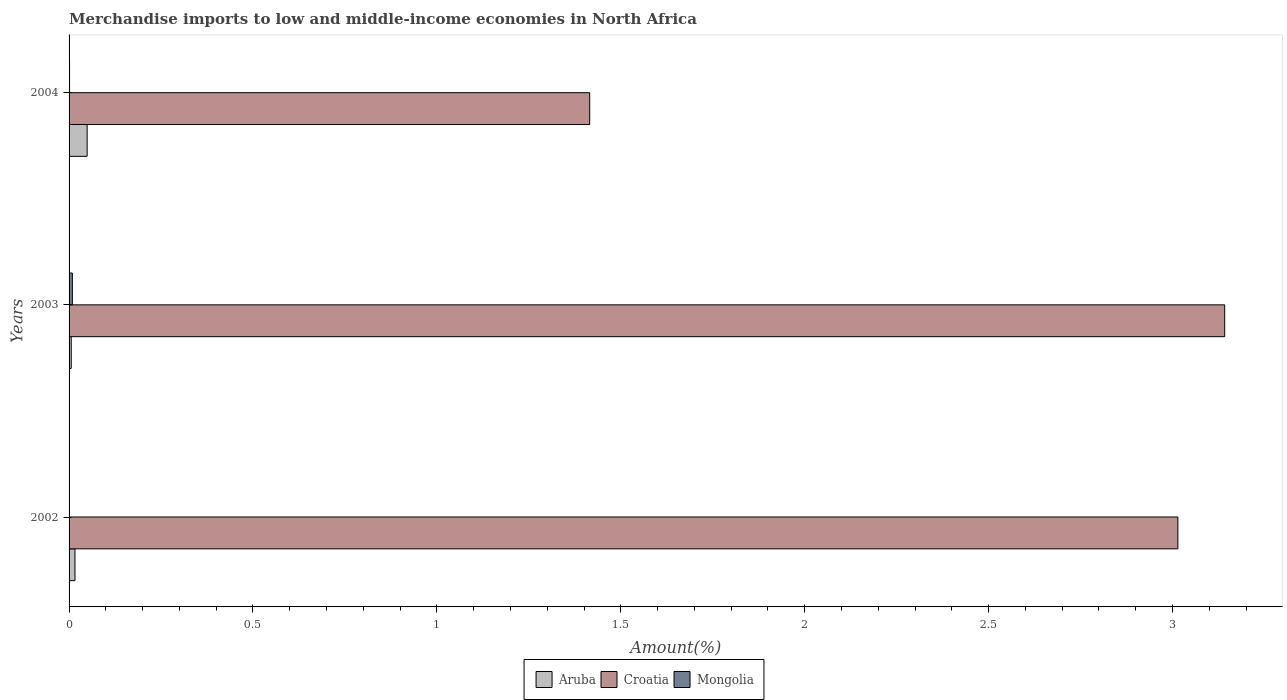Are the number of bars per tick equal to the number of legend labels?
Ensure brevity in your answer.  Yes. Are the number of bars on each tick of the Y-axis equal?
Your answer should be very brief. Yes. How many bars are there on the 2nd tick from the top?
Offer a very short reply. 3. In how many cases, is the number of bars for a given year not equal to the number of legend labels?
Provide a succinct answer. 0. What is the percentage of amount earned from merchandise imports in Croatia in 2003?
Your answer should be compact. 3.14. Across all years, what is the maximum percentage of amount earned from merchandise imports in Mongolia?
Your answer should be very brief. 0.01. Across all years, what is the minimum percentage of amount earned from merchandise imports in Aruba?
Your response must be concise. 0.01. In which year was the percentage of amount earned from merchandise imports in Aruba maximum?
Offer a very short reply. 2004. What is the total percentage of amount earned from merchandise imports in Mongolia in the graph?
Provide a succinct answer. 0.01. What is the difference between the percentage of amount earned from merchandise imports in Mongolia in 2002 and that in 2004?
Keep it short and to the point. -0. What is the difference between the percentage of amount earned from merchandise imports in Mongolia in 2004 and the percentage of amount earned from merchandise imports in Croatia in 2003?
Your answer should be very brief. -3.14. What is the average percentage of amount earned from merchandise imports in Mongolia per year?
Ensure brevity in your answer.  0. In the year 2003, what is the difference between the percentage of amount earned from merchandise imports in Aruba and percentage of amount earned from merchandise imports in Croatia?
Offer a terse response. -3.14. What is the ratio of the percentage of amount earned from merchandise imports in Mongolia in 2002 to that in 2003?
Provide a succinct answer. 0.12. Is the percentage of amount earned from merchandise imports in Mongolia in 2002 less than that in 2003?
Offer a very short reply. Yes. Is the difference between the percentage of amount earned from merchandise imports in Aruba in 2002 and 2003 greater than the difference between the percentage of amount earned from merchandise imports in Croatia in 2002 and 2003?
Give a very brief answer. Yes. What is the difference between the highest and the second highest percentage of amount earned from merchandise imports in Croatia?
Make the answer very short. 0.13. What is the difference between the highest and the lowest percentage of amount earned from merchandise imports in Aruba?
Give a very brief answer. 0.04. Is the sum of the percentage of amount earned from merchandise imports in Mongolia in 2002 and 2003 greater than the maximum percentage of amount earned from merchandise imports in Croatia across all years?
Ensure brevity in your answer.  No. What does the 2nd bar from the top in 2002 represents?
Keep it short and to the point. Croatia. What does the 3rd bar from the bottom in 2002 represents?
Offer a very short reply. Mongolia. How many bars are there?
Your answer should be very brief. 9. Are all the bars in the graph horizontal?
Ensure brevity in your answer.  Yes. How many years are there in the graph?
Make the answer very short. 3. What is the difference between two consecutive major ticks on the X-axis?
Your answer should be compact. 0.5. Does the graph contain grids?
Your answer should be very brief. No. Where does the legend appear in the graph?
Give a very brief answer. Bottom center. How many legend labels are there?
Keep it short and to the point. 3. How are the legend labels stacked?
Provide a short and direct response. Horizontal. What is the title of the graph?
Offer a very short reply. Merchandise imports to low and middle-income economies in North Africa. What is the label or title of the X-axis?
Your response must be concise. Amount(%). What is the label or title of the Y-axis?
Provide a succinct answer. Years. What is the Amount(%) in Aruba in 2002?
Offer a very short reply. 0.02. What is the Amount(%) of Croatia in 2002?
Your answer should be compact. 3.01. What is the Amount(%) of Mongolia in 2002?
Ensure brevity in your answer.  0. What is the Amount(%) in Aruba in 2003?
Provide a short and direct response. 0.01. What is the Amount(%) of Croatia in 2003?
Give a very brief answer. 3.14. What is the Amount(%) of Mongolia in 2003?
Offer a very short reply. 0.01. What is the Amount(%) in Aruba in 2004?
Ensure brevity in your answer.  0.05. What is the Amount(%) in Croatia in 2004?
Your response must be concise. 1.42. What is the Amount(%) of Mongolia in 2004?
Your response must be concise. 0. Across all years, what is the maximum Amount(%) of Aruba?
Make the answer very short. 0.05. Across all years, what is the maximum Amount(%) of Croatia?
Keep it short and to the point. 3.14. Across all years, what is the maximum Amount(%) in Mongolia?
Make the answer very short. 0.01. Across all years, what is the minimum Amount(%) in Aruba?
Your response must be concise. 0.01. Across all years, what is the minimum Amount(%) of Croatia?
Ensure brevity in your answer.  1.42. Across all years, what is the minimum Amount(%) of Mongolia?
Offer a very short reply. 0. What is the total Amount(%) of Aruba in the graph?
Your answer should be compact. 0.07. What is the total Amount(%) of Croatia in the graph?
Make the answer very short. 7.57. What is the total Amount(%) of Mongolia in the graph?
Make the answer very short. 0.01. What is the difference between the Amount(%) of Aruba in 2002 and that in 2003?
Provide a succinct answer. 0.01. What is the difference between the Amount(%) of Croatia in 2002 and that in 2003?
Provide a short and direct response. -0.13. What is the difference between the Amount(%) in Mongolia in 2002 and that in 2003?
Offer a terse response. -0.01. What is the difference between the Amount(%) in Aruba in 2002 and that in 2004?
Ensure brevity in your answer.  -0.03. What is the difference between the Amount(%) in Croatia in 2002 and that in 2004?
Give a very brief answer. 1.6. What is the difference between the Amount(%) of Mongolia in 2002 and that in 2004?
Make the answer very short. -0. What is the difference between the Amount(%) of Aruba in 2003 and that in 2004?
Offer a terse response. -0.04. What is the difference between the Amount(%) in Croatia in 2003 and that in 2004?
Your answer should be very brief. 1.73. What is the difference between the Amount(%) in Mongolia in 2003 and that in 2004?
Ensure brevity in your answer.  0.01. What is the difference between the Amount(%) of Aruba in 2002 and the Amount(%) of Croatia in 2003?
Ensure brevity in your answer.  -3.13. What is the difference between the Amount(%) of Aruba in 2002 and the Amount(%) of Mongolia in 2003?
Provide a succinct answer. 0.01. What is the difference between the Amount(%) of Croatia in 2002 and the Amount(%) of Mongolia in 2003?
Give a very brief answer. 3.01. What is the difference between the Amount(%) of Aruba in 2002 and the Amount(%) of Croatia in 2004?
Offer a very short reply. -1.4. What is the difference between the Amount(%) of Aruba in 2002 and the Amount(%) of Mongolia in 2004?
Your response must be concise. 0.01. What is the difference between the Amount(%) in Croatia in 2002 and the Amount(%) in Mongolia in 2004?
Make the answer very short. 3.01. What is the difference between the Amount(%) in Aruba in 2003 and the Amount(%) in Croatia in 2004?
Your answer should be compact. -1.41. What is the difference between the Amount(%) in Aruba in 2003 and the Amount(%) in Mongolia in 2004?
Make the answer very short. 0. What is the difference between the Amount(%) in Croatia in 2003 and the Amount(%) in Mongolia in 2004?
Make the answer very short. 3.14. What is the average Amount(%) in Aruba per year?
Make the answer very short. 0.02. What is the average Amount(%) in Croatia per year?
Provide a short and direct response. 2.52. What is the average Amount(%) of Mongolia per year?
Give a very brief answer. 0. In the year 2002, what is the difference between the Amount(%) of Aruba and Amount(%) of Croatia?
Your answer should be very brief. -3. In the year 2002, what is the difference between the Amount(%) of Aruba and Amount(%) of Mongolia?
Provide a succinct answer. 0.01. In the year 2002, what is the difference between the Amount(%) in Croatia and Amount(%) in Mongolia?
Make the answer very short. 3.01. In the year 2003, what is the difference between the Amount(%) in Aruba and Amount(%) in Croatia?
Give a very brief answer. -3.14. In the year 2003, what is the difference between the Amount(%) in Aruba and Amount(%) in Mongolia?
Your response must be concise. -0. In the year 2003, what is the difference between the Amount(%) in Croatia and Amount(%) in Mongolia?
Offer a very short reply. 3.13. In the year 2004, what is the difference between the Amount(%) of Aruba and Amount(%) of Croatia?
Keep it short and to the point. -1.37. In the year 2004, what is the difference between the Amount(%) in Aruba and Amount(%) in Mongolia?
Give a very brief answer. 0.05. In the year 2004, what is the difference between the Amount(%) of Croatia and Amount(%) of Mongolia?
Offer a terse response. 1.41. What is the ratio of the Amount(%) in Aruba in 2002 to that in 2003?
Keep it short and to the point. 2.75. What is the ratio of the Amount(%) in Croatia in 2002 to that in 2003?
Provide a succinct answer. 0.96. What is the ratio of the Amount(%) of Mongolia in 2002 to that in 2003?
Provide a short and direct response. 0.12. What is the ratio of the Amount(%) of Aruba in 2002 to that in 2004?
Provide a short and direct response. 0.33. What is the ratio of the Amount(%) in Croatia in 2002 to that in 2004?
Your answer should be compact. 2.13. What is the ratio of the Amount(%) in Mongolia in 2002 to that in 2004?
Ensure brevity in your answer.  0.8. What is the ratio of the Amount(%) in Aruba in 2003 to that in 2004?
Offer a very short reply. 0.12. What is the ratio of the Amount(%) of Croatia in 2003 to that in 2004?
Offer a terse response. 2.22. What is the ratio of the Amount(%) in Mongolia in 2003 to that in 2004?
Provide a succinct answer. 6.65. What is the difference between the highest and the second highest Amount(%) in Aruba?
Offer a very short reply. 0.03. What is the difference between the highest and the second highest Amount(%) in Croatia?
Offer a terse response. 0.13. What is the difference between the highest and the second highest Amount(%) in Mongolia?
Offer a very short reply. 0.01. What is the difference between the highest and the lowest Amount(%) in Aruba?
Ensure brevity in your answer.  0.04. What is the difference between the highest and the lowest Amount(%) of Croatia?
Your response must be concise. 1.73. What is the difference between the highest and the lowest Amount(%) in Mongolia?
Offer a very short reply. 0.01. 